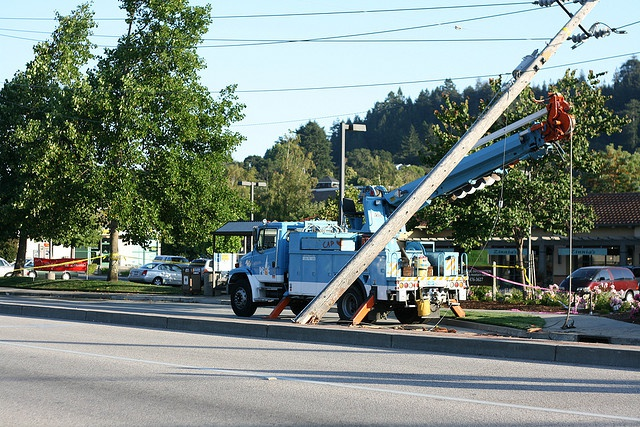Describe the objects in this image and their specific colors. I can see truck in lightblue, black, blue, and white tones, car in lightblue, black, gray, and brown tones, car in lightblue, black, gray, and blue tones, car in lightblue, gray, white, black, and darkgray tones, and car in lightblue, black, white, and gray tones in this image. 